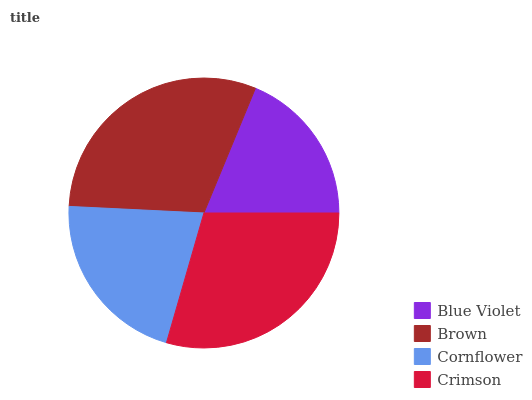Is Blue Violet the minimum?
Answer yes or no. Yes. Is Brown the maximum?
Answer yes or no. Yes. Is Cornflower the minimum?
Answer yes or no. No. Is Cornflower the maximum?
Answer yes or no. No. Is Brown greater than Cornflower?
Answer yes or no. Yes. Is Cornflower less than Brown?
Answer yes or no. Yes. Is Cornflower greater than Brown?
Answer yes or no. No. Is Brown less than Cornflower?
Answer yes or no. No. Is Crimson the high median?
Answer yes or no. Yes. Is Cornflower the low median?
Answer yes or no. Yes. Is Brown the high median?
Answer yes or no. No. Is Crimson the low median?
Answer yes or no. No. 